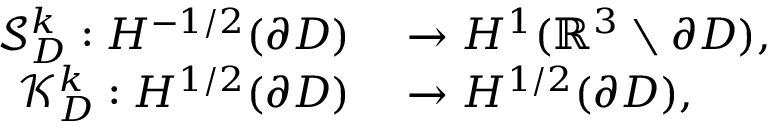Convert formula to latex. <formula><loc_0><loc_0><loc_500><loc_500>\begin{array} { r l } { \mathcal { S } _ { D } ^ { k } \colon H ^ { - 1 / 2 } ( \partial D ) } & \rightarrow H ^ { 1 } ( \mathbb { R } ^ { 3 } \ \partial D ) , } \\ { \mathcal { K } _ { D } ^ { k } \colon H ^ { 1 / 2 } ( \partial D ) } & \rightarrow H ^ { 1 / 2 } ( \partial D ) , } \end{array}</formula> 